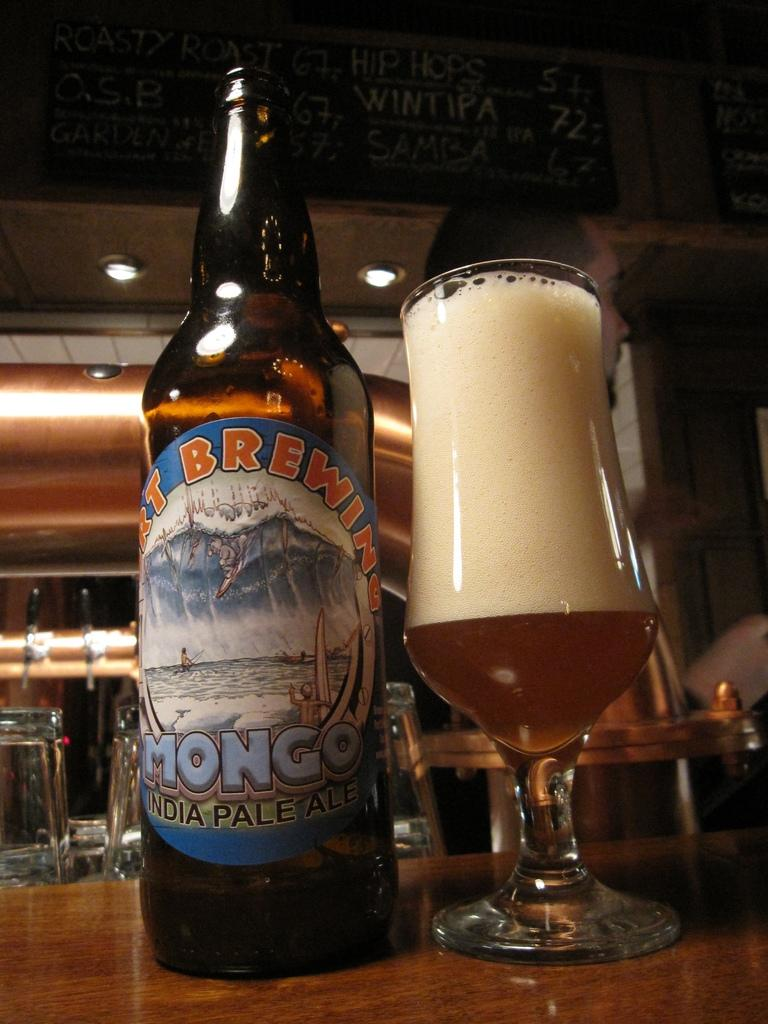Provide a one-sentence caption for the provided image. A bottle of India pale ale sits next to a full glass. 